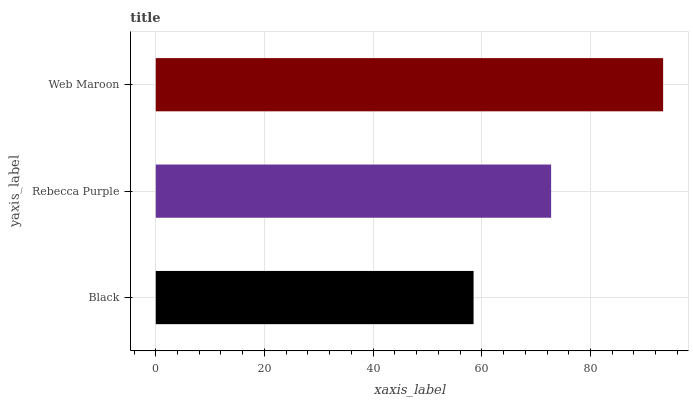Is Black the minimum?
Answer yes or no. Yes. Is Web Maroon the maximum?
Answer yes or no. Yes. Is Rebecca Purple the minimum?
Answer yes or no. No. Is Rebecca Purple the maximum?
Answer yes or no. No. Is Rebecca Purple greater than Black?
Answer yes or no. Yes. Is Black less than Rebecca Purple?
Answer yes or no. Yes. Is Black greater than Rebecca Purple?
Answer yes or no. No. Is Rebecca Purple less than Black?
Answer yes or no. No. Is Rebecca Purple the high median?
Answer yes or no. Yes. Is Rebecca Purple the low median?
Answer yes or no. Yes. Is Black the high median?
Answer yes or no. No. Is Black the low median?
Answer yes or no. No. 